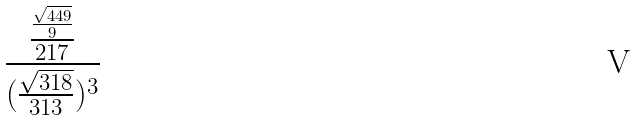Convert formula to latex. <formula><loc_0><loc_0><loc_500><loc_500>\frac { \frac { \frac { \sqrt { 4 4 9 } } { 9 } } { 2 1 7 } } { ( \frac { \sqrt { 3 1 8 } } { 3 1 3 } ) ^ { 3 } }</formula> 